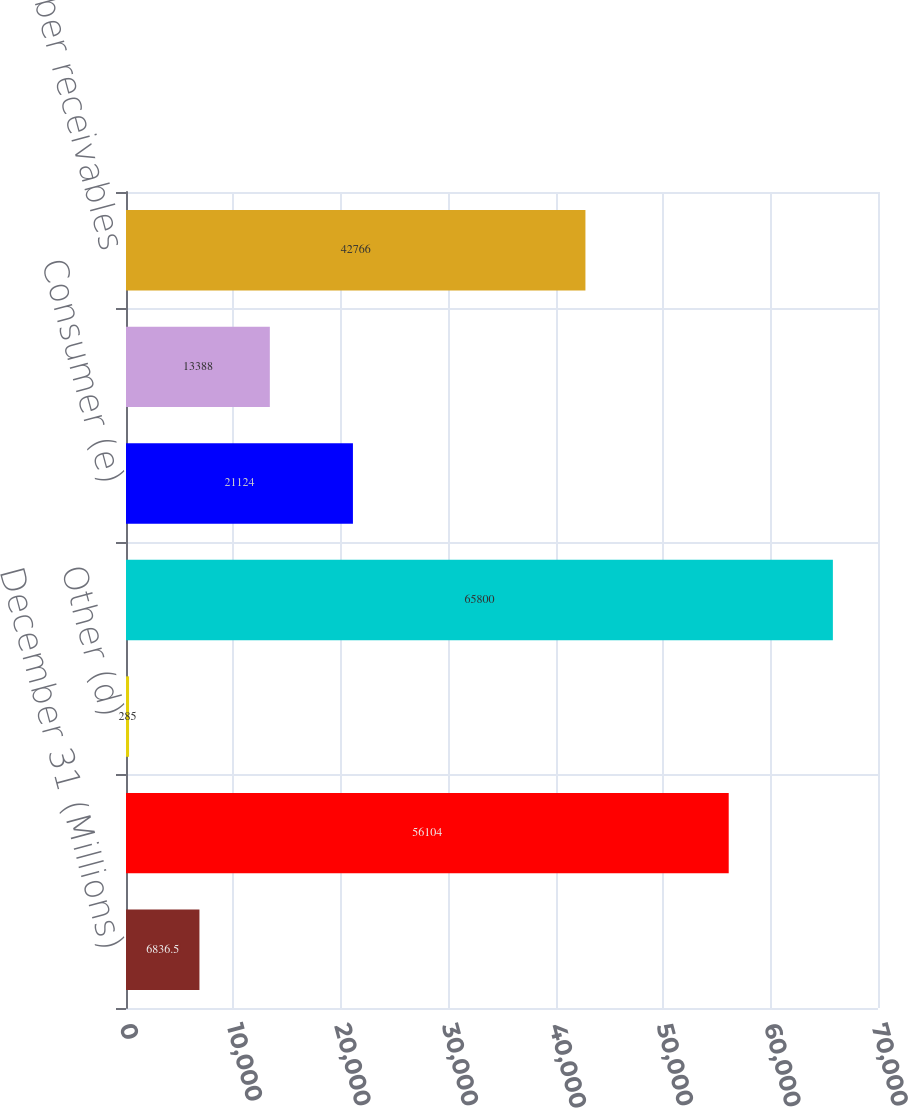Convert chart to OTSL. <chart><loc_0><loc_0><loc_500><loc_500><bar_chart><fcel>December 31 (Millions)<fcel>Card Member (c)<fcel>Other (d)<fcel>Total loans<fcel>Consumer (e)<fcel>Commercial (f)<fcel>Total Card Member receivables<nl><fcel>6836.5<fcel>56104<fcel>285<fcel>65800<fcel>21124<fcel>13388<fcel>42766<nl></chart> 